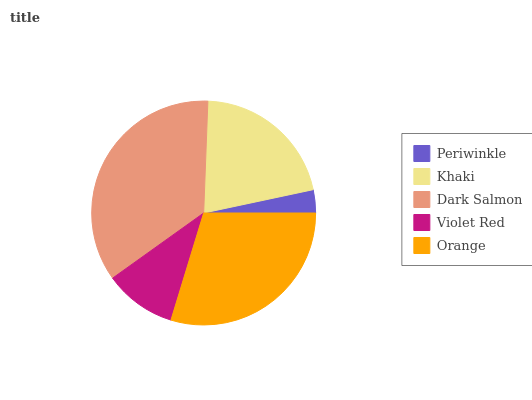Is Periwinkle the minimum?
Answer yes or no. Yes. Is Dark Salmon the maximum?
Answer yes or no. Yes. Is Khaki the minimum?
Answer yes or no. No. Is Khaki the maximum?
Answer yes or no. No. Is Khaki greater than Periwinkle?
Answer yes or no. Yes. Is Periwinkle less than Khaki?
Answer yes or no. Yes. Is Periwinkle greater than Khaki?
Answer yes or no. No. Is Khaki less than Periwinkle?
Answer yes or no. No. Is Khaki the high median?
Answer yes or no. Yes. Is Khaki the low median?
Answer yes or no. Yes. Is Dark Salmon the high median?
Answer yes or no. No. Is Orange the low median?
Answer yes or no. No. 